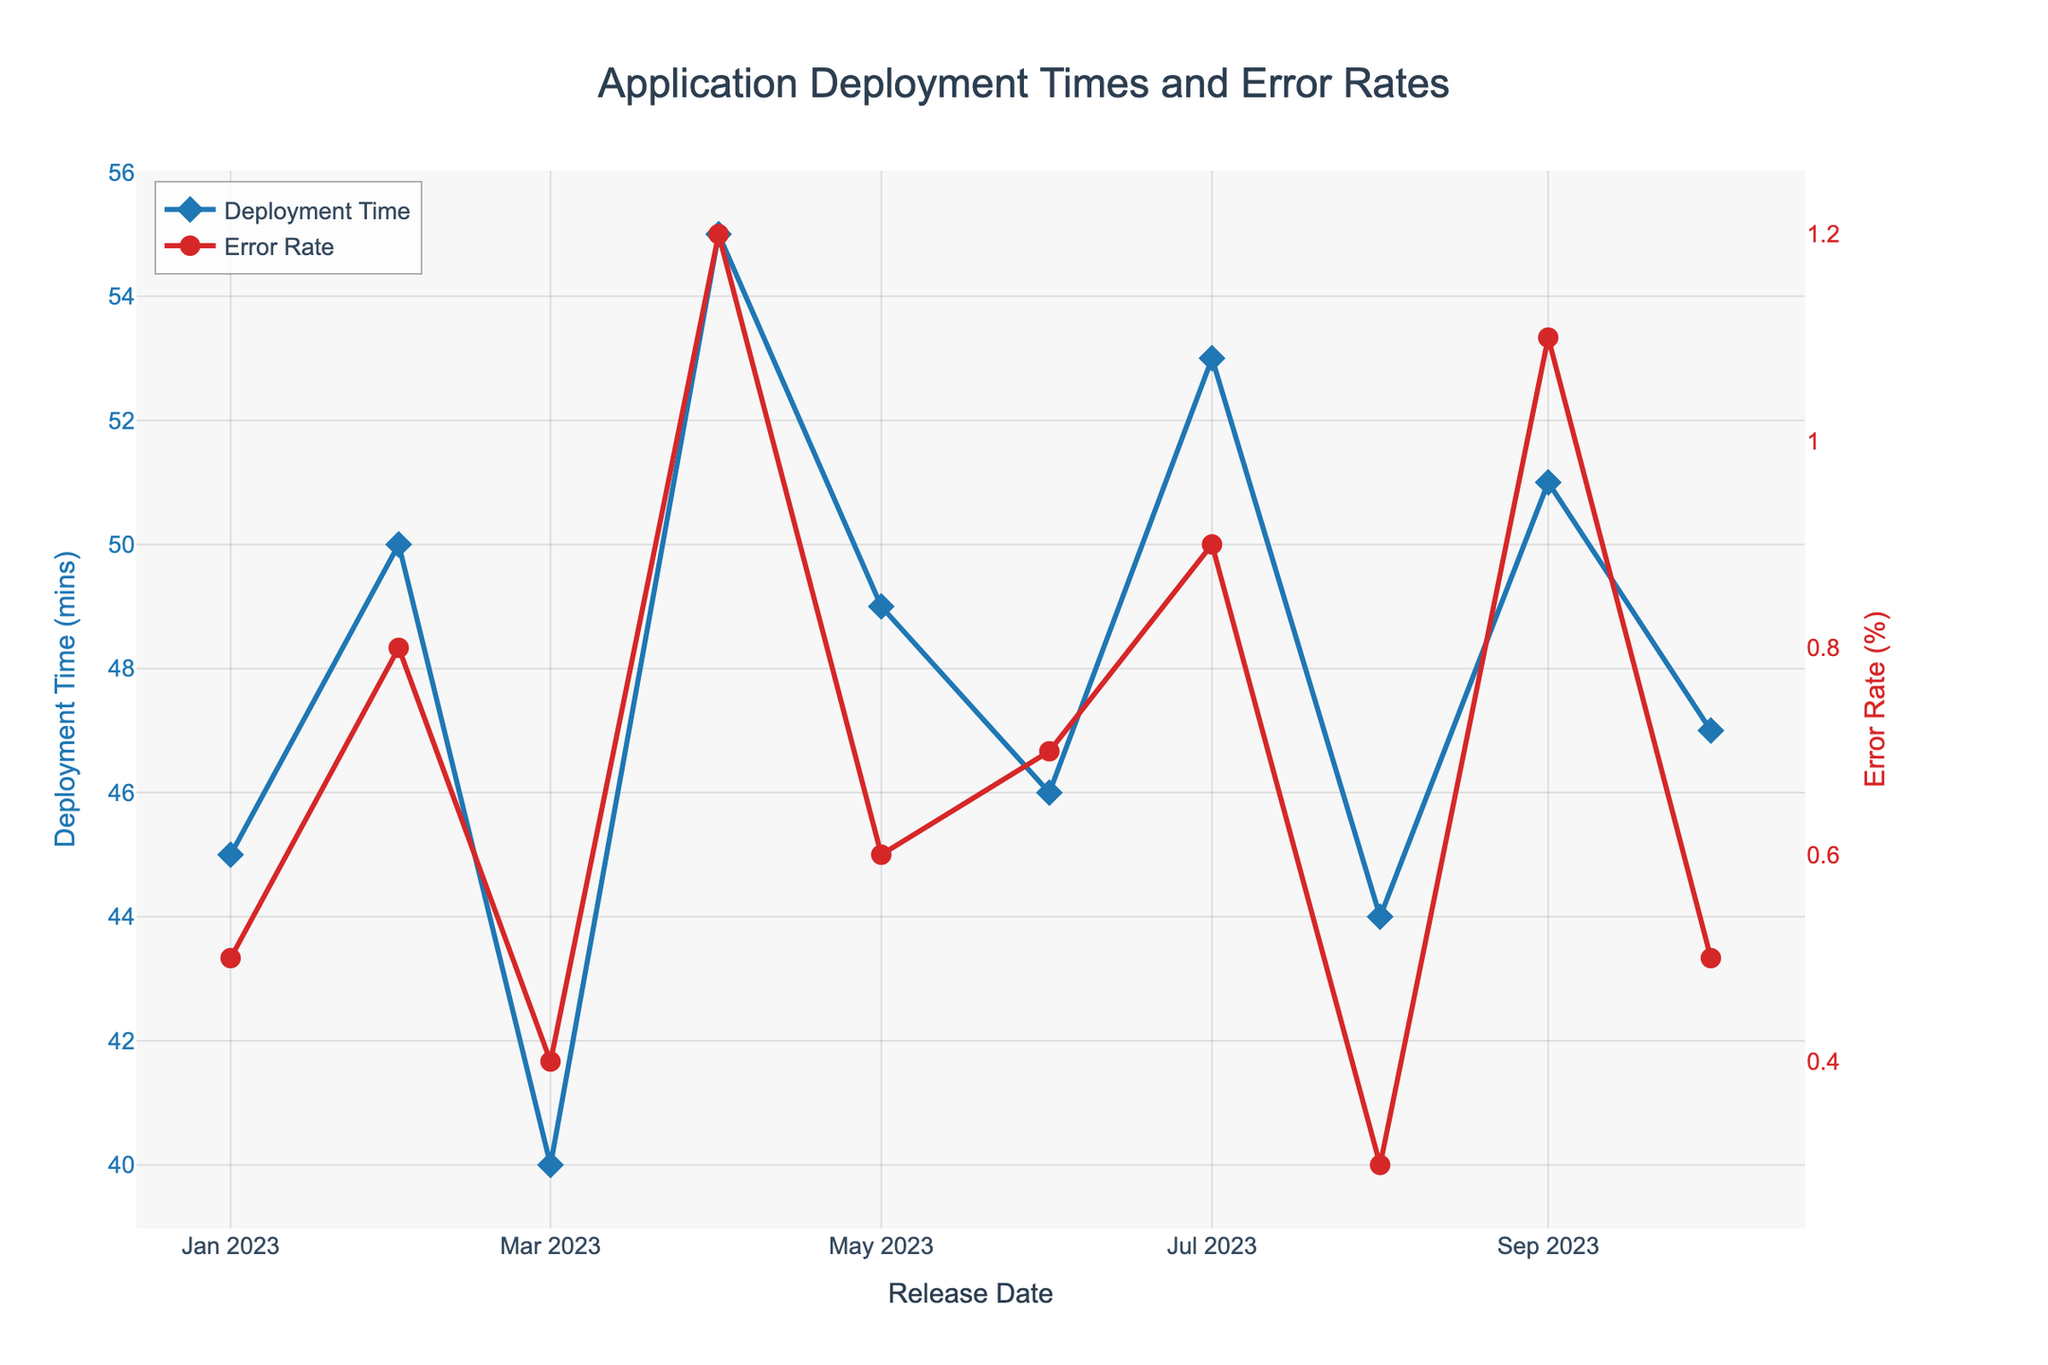What's the title of the plot? The title is presented at the top center of the figure. It reads "Application Deployment Times and Error Rates".
Answer: Application Deployment Times and Error Rates What is the deployment time for the release in April 2023? The deployment time is denoted by the blue diamonds on the primary y-axis. For April 2023, this value is 55 minutes.
Answer: 55 minutes How does the error rate in August 2023 compare to that in April 2023? The error rate is indicated by red circles on the secondary y-axis. For August 2023, it is 0.3%, and for April 2023, it is 1.2%. Hence, the error rate in August is lower than in April.
Answer: Lower What is the range of error rates observed across all releases? The error rates range from the minimum observed (0.3% in August 2023) to the maximum observed (1.2% in April 2023).
Answer: 0.3% to 1.2% Which release had the highest deployment time? Observing the blue diamonds, the highest point on the primary y-axis corresponds to April 2023 with a deployment time of 55 minutes.
Answer: April 2023 Calculate the average deployment time over all releases. Sum all deployment times (45 + 50 + 40 + 55 + 49 + 46 + 53 + 44 + 51 + 47 = 480) and divide by the number of releases (10) to get the average. 480 / 10 = 48 minutes.
Answer: 48 minutes Do any releases have the same deployment time? Upon inspecting the deployment times indicated by blue diamonds on the primary y-axis, no two releases share the same deployment time.
Answer: No Between which consecutive releases did the error rate increase the most? By examining the red circles representing error rates, the largest increase is from March 2023 (0.4%) to April 2023 (1.2%), an increase of 0.8%.
Answer: March to April 2023 